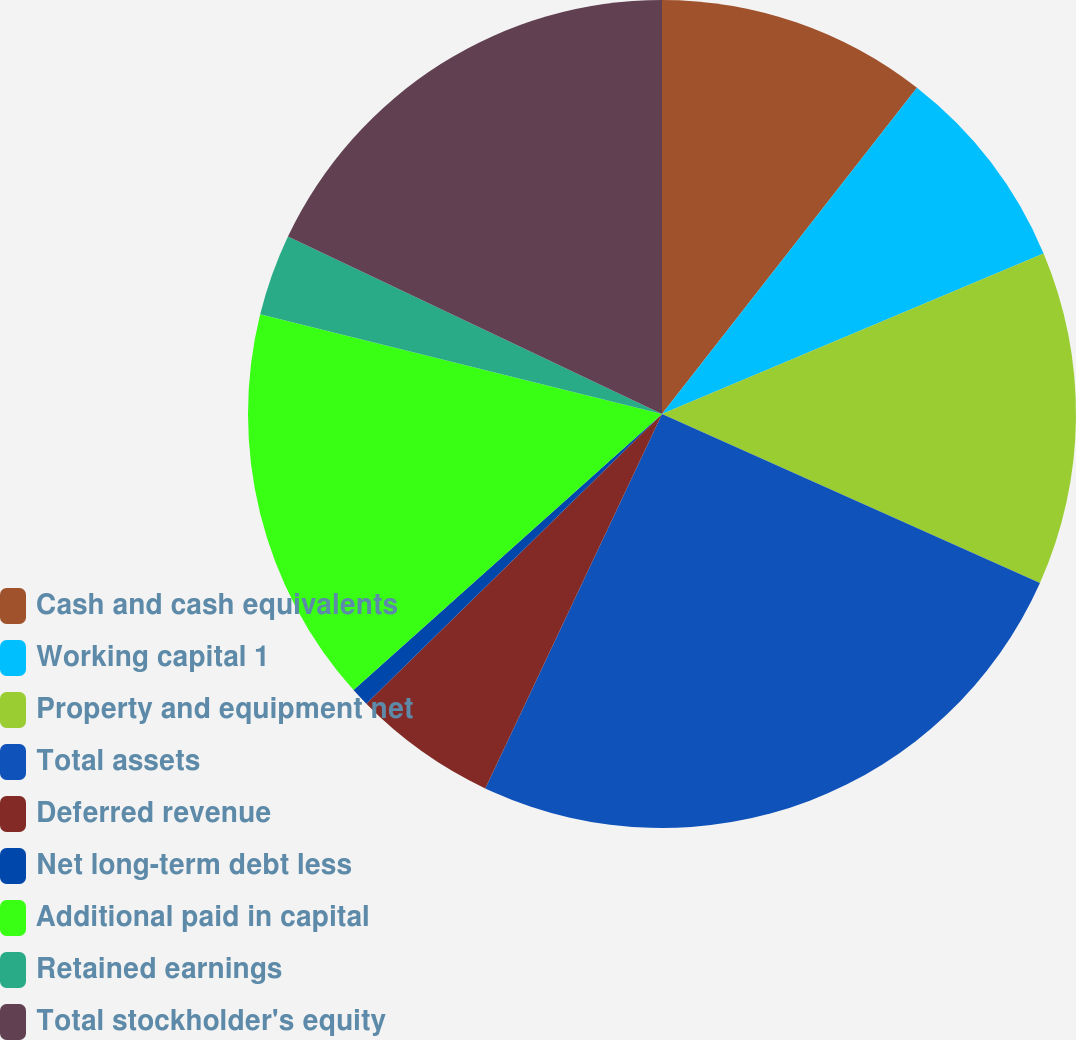Convert chart to OTSL. <chart><loc_0><loc_0><loc_500><loc_500><pie_chart><fcel>Cash and cash equivalents<fcel>Working capital 1<fcel>Property and equipment net<fcel>Total assets<fcel>Deferred revenue<fcel>Net long-term debt less<fcel>Additional paid in capital<fcel>Retained earnings<fcel>Total stockholder's equity<nl><fcel>10.56%<fcel>8.1%<fcel>13.03%<fcel>25.33%<fcel>5.64%<fcel>0.72%<fcel>15.49%<fcel>3.18%<fcel>17.95%<nl></chart> 